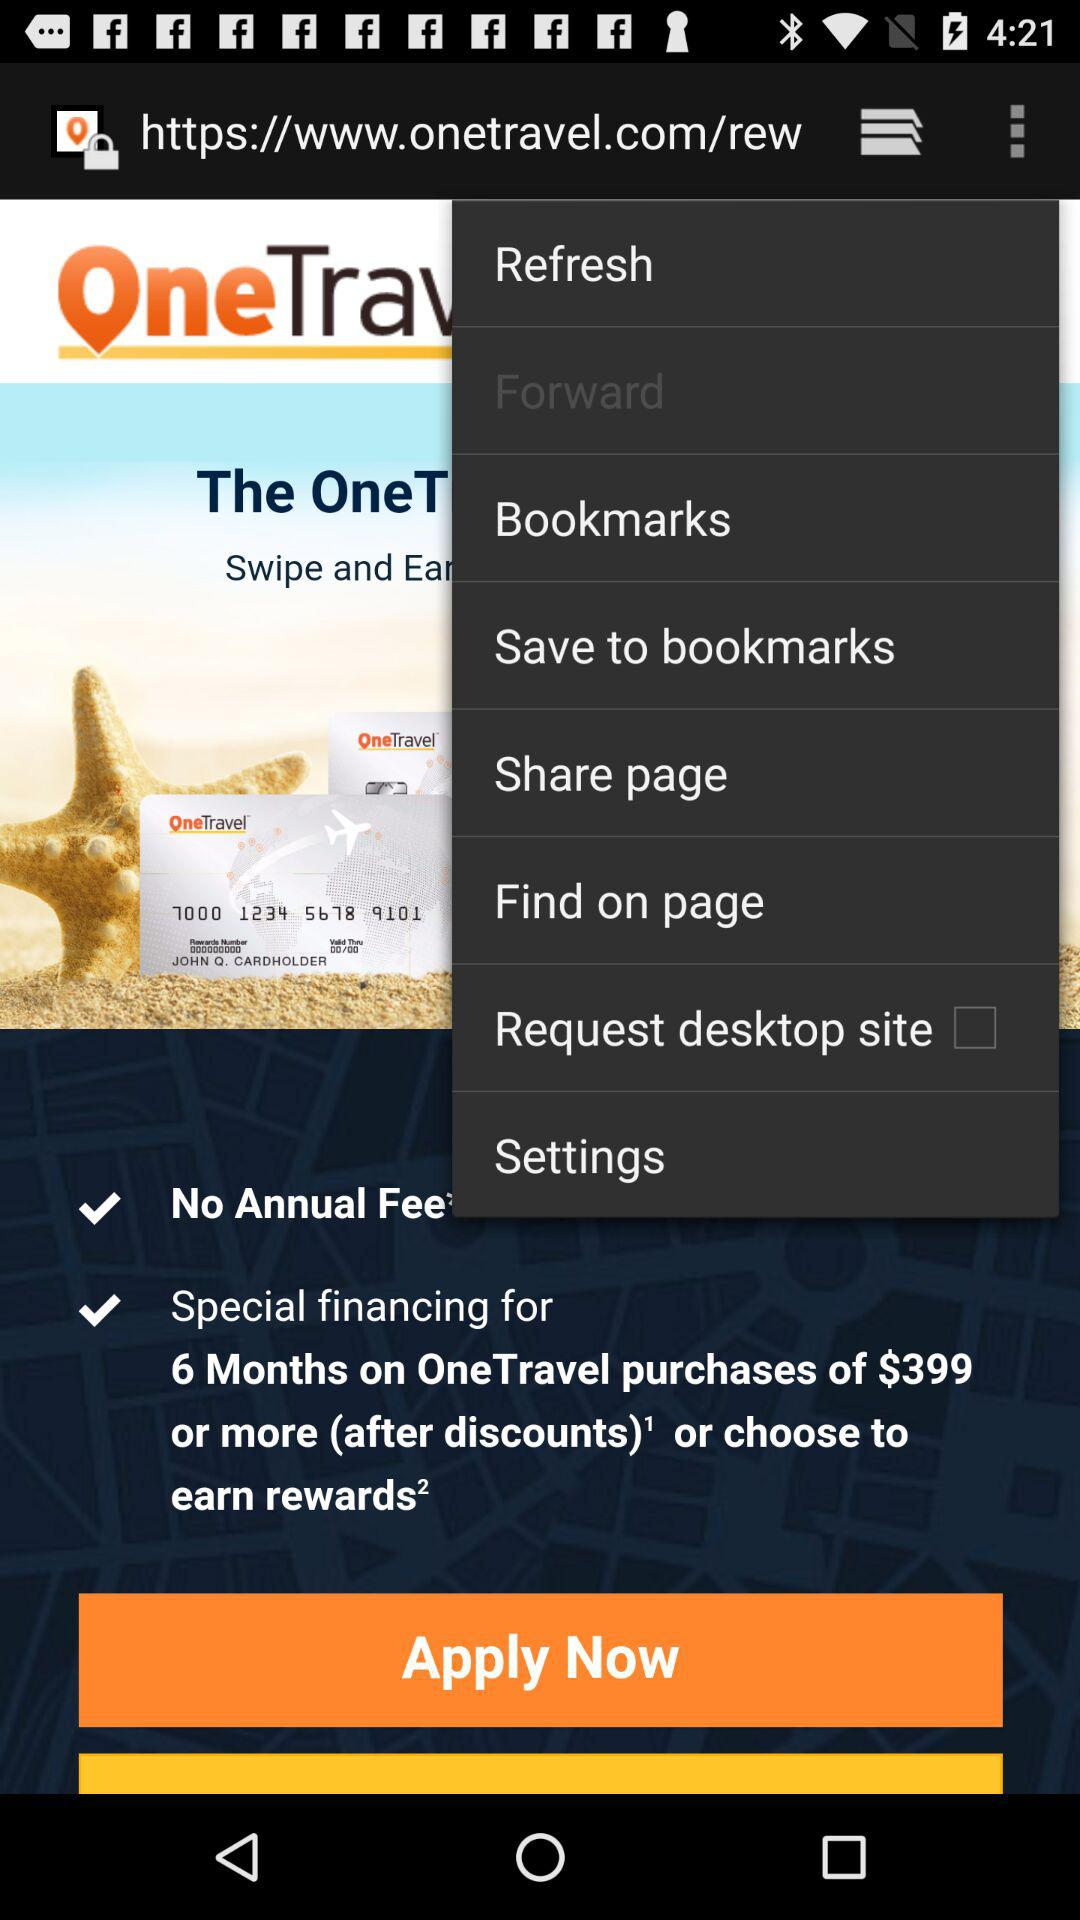What's the purchases of Travels?
When the provided information is insufficient, respond with <no answer>. <no answer> 